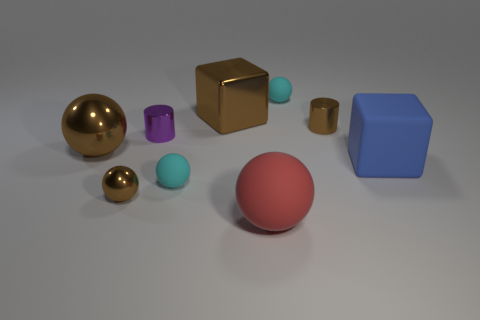How many cylinders are large blue rubber objects or brown things?
Offer a very short reply. 1. There is a big blue thing; what shape is it?
Give a very brief answer. Cube. Are there any cyan balls to the left of the red ball?
Your response must be concise. Yes. Is the material of the blue block the same as the block behind the blue rubber object?
Your answer should be very brief. No. Do the small cyan thing on the right side of the large red matte thing and the blue matte object have the same shape?
Give a very brief answer. No. How many tiny yellow spheres are made of the same material as the purple cylinder?
Provide a succinct answer. 0. What number of things are small cyan spheres that are in front of the large brown sphere or big blue matte cubes?
Your answer should be very brief. 2. How big is the brown metal cylinder?
Offer a terse response. Small. There is a tiny cyan object that is to the left of the tiny cyan thing that is on the right side of the big red thing; what is it made of?
Make the answer very short. Rubber. There is a cyan matte sphere that is to the right of the metallic cube; is its size the same as the big shiny sphere?
Provide a succinct answer. No. 